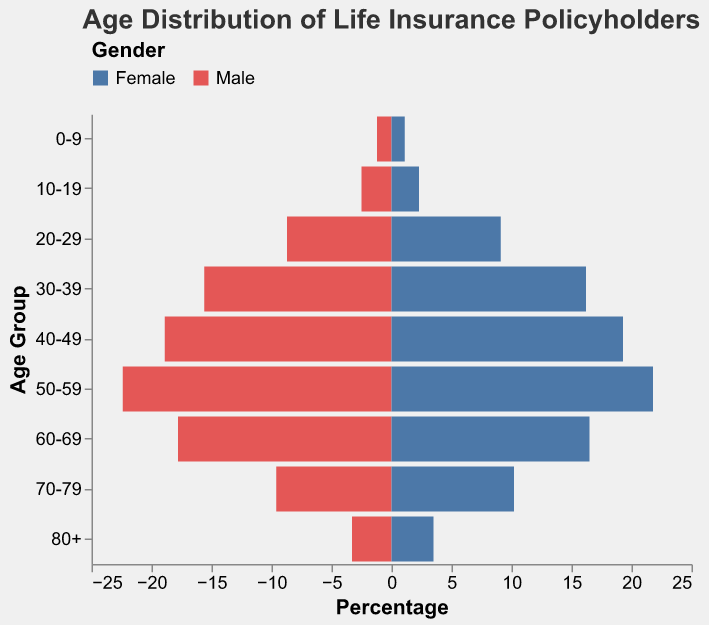How does the percentage of male policyholders aged 50-59 compare to that of female policyholders in the same age group? To compare the percentages, locate the bars representing the 50-59 age group on the pyramid. The male percentage is 22.4%, while the female percentage is 21.8%.
Answer: The percentage of male policyholders is higher What is the total percentage of policyholders in the 30-39 age group? To find the total percentage, sum the percentages of both males and females in the 30-39 age group. Male percentage is 15.6%, and female percentage is 16.2%. Total = 15.6% + 16.2% = 31.8%.
Answer: 31.8% Which age group has the highest percentage of female policyholders? The highest bar on the female side will represent the maximum percentage. The highest percentage for females is in the 40-49 age group at 19.3%.
Answer: 40-49 For which age groups do female policyholders outnumber male policyholders? To determine this, compare the percentages for each age group. Females outnumber males in: 20-29 (9.1% > 8.7%), 30-39 (16.2% > 15.6%), 40-49 (19.3% > 18.9%), and 70-79 (10.2% > 9.6%).
Answer: 20-29, 30-39, 40-49, 70-79 What is the combined percentage of policyholders aged 60-69? Add the male and female percentages for the 60-69 age group: Male 17.8%, Female 16.5%. Total = 17.8% + 16.5% = 34.3%.
Answer: 34.3% Which age group shows the smallest difference in percentage between male and female policyholders? Calculate the absolute difference between male and female percentages for each age group. The smallest difference is in the 50-59 age group, with a difference of 0.6% (22.4% - 21.8%).
Answer: 50-59 What is the median age group for both male and female policyholders, considering the percentages? To find the median, arrange the age groups in ascending order of their percentages and find the middle value. For males, the median is the 40-49 age group (50-59 is slightly higher and 30-39 is slightly lower). For females, it is also the 40-49 age group.
Answer: 40-49 How does the distribution of male and female policyholders change across age groups? Observe how the bars shift from one age group to the next in the pyramid. Initially, male and female percentages are close, but differences become more noticeable in middle age (30-59). The late-age groups (60+) show a decline in both percentages with slight variations.
Answer: Men and women have close percentages at younger and older ages, with men leading in mid-age In which age group do male policyholders have their highest percentage of total policyholders? Identify the tallest bar on the male side of the pyramid. The highest percentage for male policyholders is in the 50-59 age group at 22.4%.
Answer: 50-59 